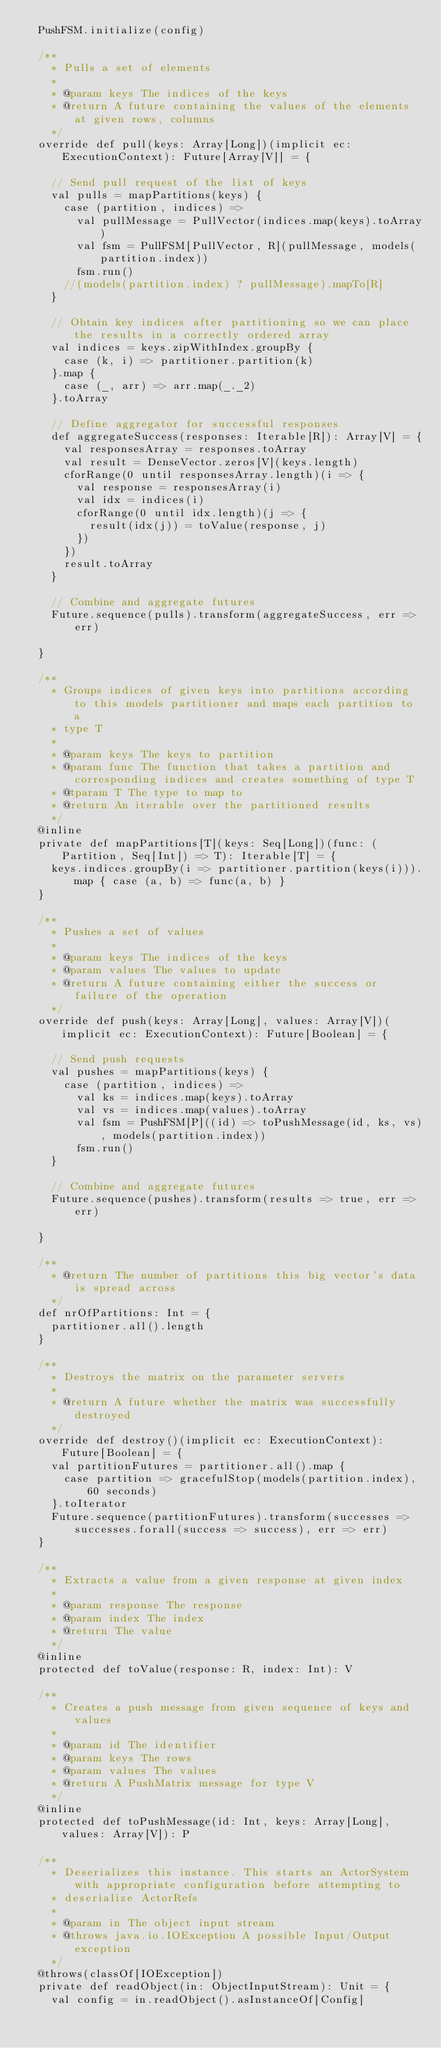<code> <loc_0><loc_0><loc_500><loc_500><_Scala_>  PushFSM.initialize(config)

  /**
    * Pulls a set of elements
    *
    * @param keys The indices of the keys
    * @return A future containing the values of the elements at given rows, columns
    */
  override def pull(keys: Array[Long])(implicit ec: ExecutionContext): Future[Array[V]] = {

    // Send pull request of the list of keys
    val pulls = mapPartitions(keys) {
      case (partition, indices) =>
        val pullMessage = PullVector(indices.map(keys).toArray)
        val fsm = PullFSM[PullVector, R](pullMessage, models(partition.index))
        fsm.run()
      //(models(partition.index) ? pullMessage).mapTo[R]
    }

    // Obtain key indices after partitioning so we can place the results in a correctly ordered array
    val indices = keys.zipWithIndex.groupBy {
      case (k, i) => partitioner.partition(k)
    }.map {
      case (_, arr) => arr.map(_._2)
    }.toArray

    // Define aggregator for successful responses
    def aggregateSuccess(responses: Iterable[R]): Array[V] = {
      val responsesArray = responses.toArray
      val result = DenseVector.zeros[V](keys.length)
      cforRange(0 until responsesArray.length)(i => {
        val response = responsesArray(i)
        val idx = indices(i)
        cforRange(0 until idx.length)(j => {
          result(idx(j)) = toValue(response, j)
        })
      })
      result.toArray
    }

    // Combine and aggregate futures
    Future.sequence(pulls).transform(aggregateSuccess, err => err)

  }

  /**
    * Groups indices of given keys into partitions according to this models partitioner and maps each partition to a
    * type T
    *
    * @param keys The keys to partition
    * @param func The function that takes a partition and corresponding indices and creates something of type T
    * @tparam T The type to map to
    * @return An iterable over the partitioned results
    */
  @inline
  private def mapPartitions[T](keys: Seq[Long])(func: (Partition, Seq[Int]) => T): Iterable[T] = {
    keys.indices.groupBy(i => partitioner.partition(keys(i))).map { case (a, b) => func(a, b) }
  }

  /**
    * Pushes a set of values
    *
    * @param keys The indices of the keys
    * @param values The values to update
    * @return A future containing either the success or failure of the operation
    */
  override def push(keys: Array[Long], values: Array[V])(implicit ec: ExecutionContext): Future[Boolean] = {

    // Send push requests
    val pushes = mapPartitions(keys) {
      case (partition, indices) =>
        val ks = indices.map(keys).toArray
        val vs = indices.map(values).toArray
        val fsm = PushFSM[P]((id) => toPushMessage(id, ks, vs), models(partition.index))
        fsm.run()
    }

    // Combine and aggregate futures
    Future.sequence(pushes).transform(results => true, err => err)

  }

  /**
    * @return The number of partitions this big vector's data is spread across
    */
  def nrOfPartitions: Int = {
    partitioner.all().length
  }

  /**
    * Destroys the matrix on the parameter servers
    *
    * @return A future whether the matrix was successfully destroyed
    */
  override def destroy()(implicit ec: ExecutionContext): Future[Boolean] = {
    val partitionFutures = partitioner.all().map {
      case partition => gracefulStop(models(partition.index), 60 seconds)
    }.toIterator
    Future.sequence(partitionFutures).transform(successes => successes.forall(success => success), err => err)
  }

  /**
    * Extracts a value from a given response at given index
    *
    * @param response The response
    * @param index The index
    * @return The value
    */
  @inline
  protected def toValue(response: R, index: Int): V

  /**
    * Creates a push message from given sequence of keys and values
    *
    * @param id The identifier
    * @param keys The rows
    * @param values The values
    * @return A PushMatrix message for type V
    */
  @inline
  protected def toPushMessage(id: Int, keys: Array[Long], values: Array[V]): P

  /**
    * Deserializes this instance. This starts an ActorSystem with appropriate configuration before attempting to
    * deserialize ActorRefs
    *
    * @param in The object input stream
    * @throws java.io.IOException A possible Input/Output exception
    */
  @throws(classOf[IOException])
  private def readObject(in: ObjectInputStream): Unit = {
    val config = in.readObject().asInstanceOf[Config]</code> 